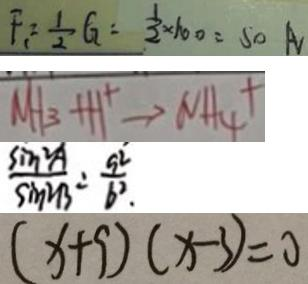Convert formula to latex. <formula><loc_0><loc_0><loc_500><loc_500>F _ { 1 } = \frac { 1 } { 2 } G = \frac { 1 } { 2 } \times 1 0 0 = 5 0 A 
 M H _ { 3 } + H ^ { + } \rightarrow N H _ { 4 } + 
 \frac { \sin ^ { 2 } A } { \sin ^ { 2 } B } = \frac { 9 ^ { 2 } } { b ^ { 2 } } 
 ( x + 9 ) ( x - 3 ) = 0</formula> 